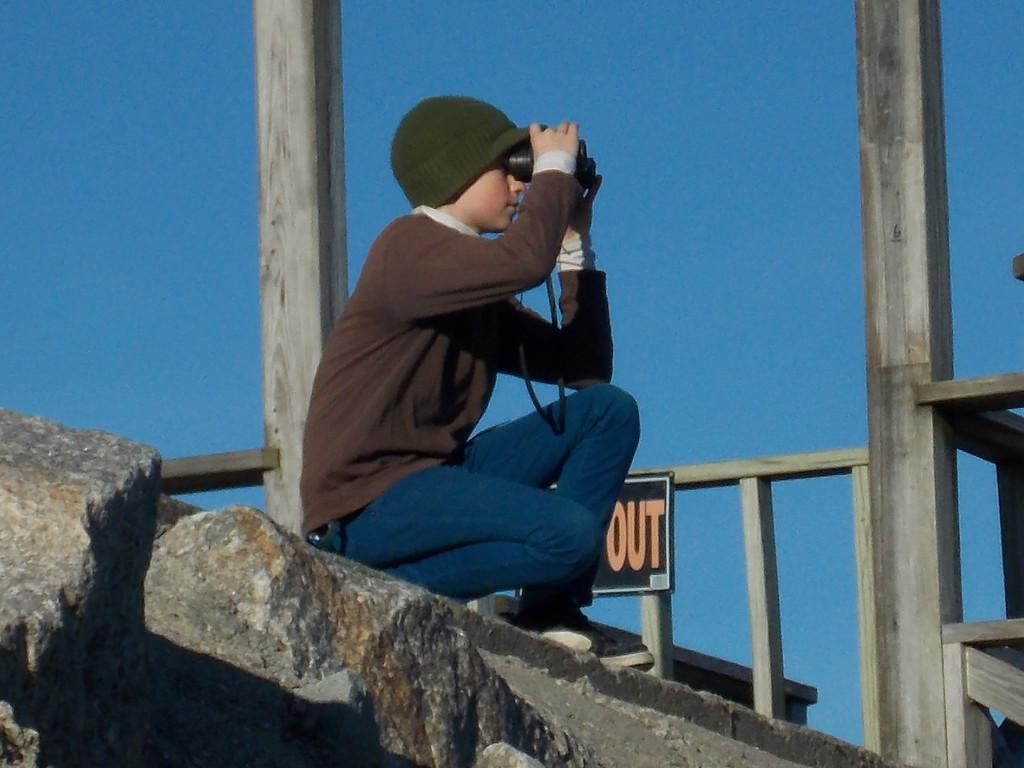What is the person in the image doing? The person is sitting on a rock in the image. What is the person holding while sitting on the rock? The person is holding a camera. What can be seen on the right side of the image? There is a building on the right side of the image. What is visible in the background of the image? The sky is visible in the background of the image. What type of linen is being used to answer questions about the image? There is no linen present in the image, nor is it being used to answer questions about the image. 